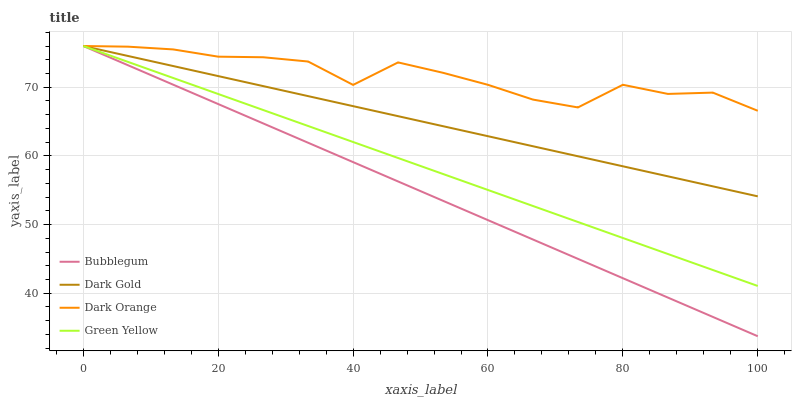Does Bubblegum have the minimum area under the curve?
Answer yes or no. Yes. Does Dark Orange have the maximum area under the curve?
Answer yes or no. Yes. Does Green Yellow have the minimum area under the curve?
Answer yes or no. No. Does Green Yellow have the maximum area under the curve?
Answer yes or no. No. Is Bubblegum the smoothest?
Answer yes or no. Yes. Is Dark Orange the roughest?
Answer yes or no. Yes. Is Green Yellow the smoothest?
Answer yes or no. No. Is Green Yellow the roughest?
Answer yes or no. No. Does Bubblegum have the lowest value?
Answer yes or no. Yes. Does Green Yellow have the lowest value?
Answer yes or no. No. Does Dark Gold have the highest value?
Answer yes or no. Yes. Does Dark Orange intersect Bubblegum?
Answer yes or no. Yes. Is Dark Orange less than Bubblegum?
Answer yes or no. No. Is Dark Orange greater than Bubblegum?
Answer yes or no. No. 